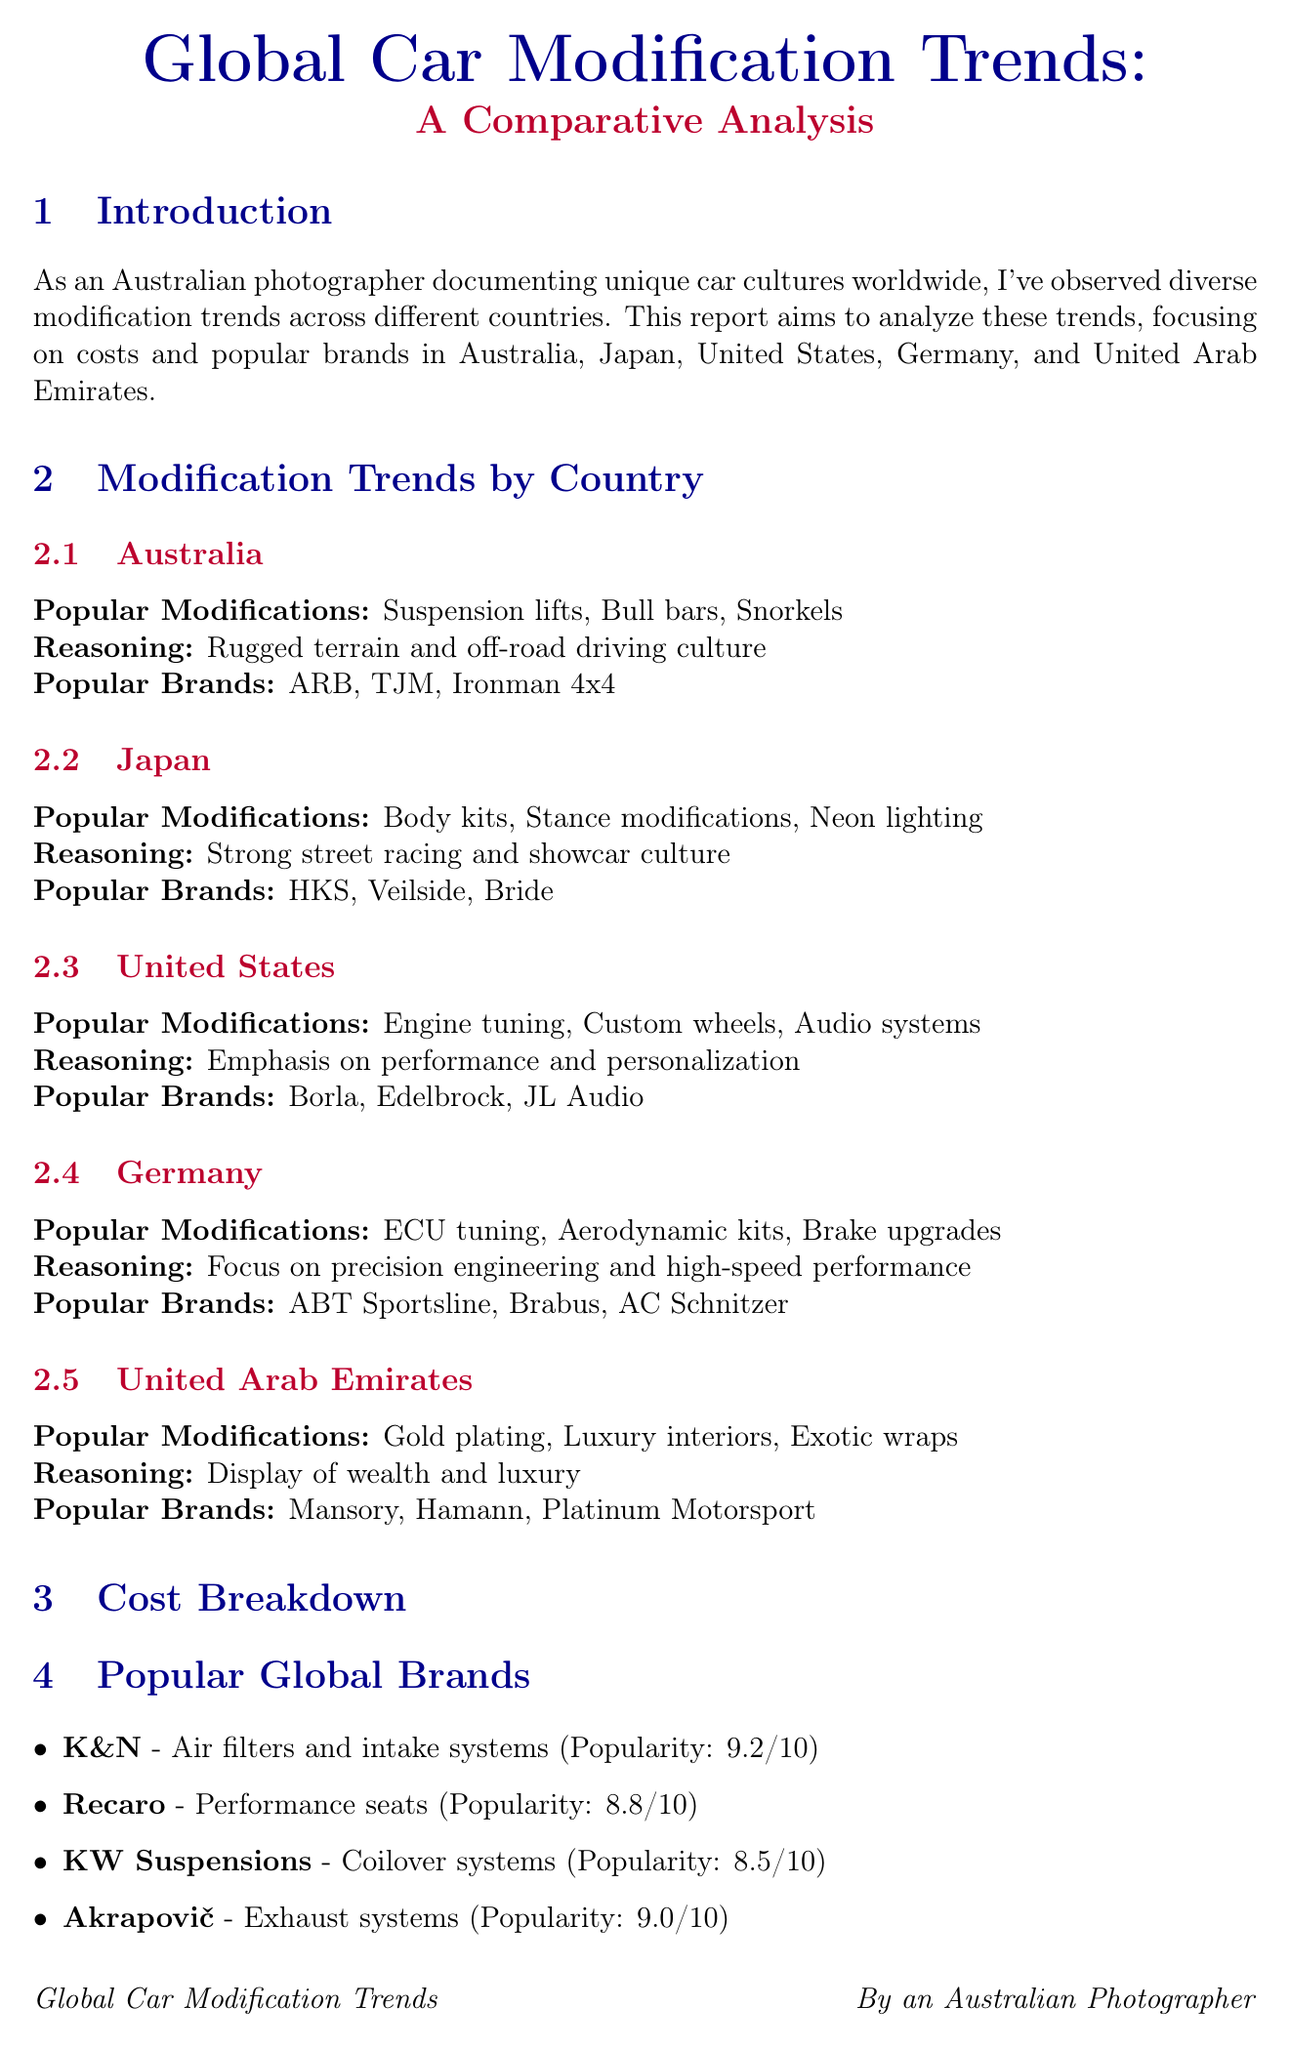what are the popular modifications in Australia? The section on Australia lists the popular modifications, which are Suspension lifts, Bull bars, and Snorkels.
Answer: Suspension lifts, Bull bars, Snorkels which country has the highest average cost for body kits? The cost breakdown table shows the average costs for body kits across different countries, with United Arab Emirates having the highest cost at 5000 USD.
Answer: United Arab Emirates what is the reasoning for popular modifications in Germany? The report mentions that the reasoning for popular modifications in Germany is the focus on precision engineering and high-speed performance.
Answer: Precision engineering and high-speed performance name a popular brand in Japan. The Japan section lists popular brands, including HKS, Veilside, and Bride.
Answer: HKS how much does engine tuning cost on average in the United States? The average cost for engine tuning in the cost breakdown table for the United States is 2800 USD.
Answer: 2800 which social media platform is mentioned as influential? The social media impact section lists Instagram, YouTube, and TikTok as popular platforms.
Answer: Instagram what is one expected future trend in car modifications? The conclusion states that there is an increasing focus on eco-friendly modifications and electric vehicle customization.
Answer: Eco-friendly modifications which country is known for luxury modifications such as gold plating? The UAE section highlights modifications like gold plating, indicating that the country is known for luxury modifications.
Answer: United Arab Emirates what is the popularity score of Akrapovič? The popular global brands section gives Akrapovič a popularity score of 9.0.
Answer: 9.0 